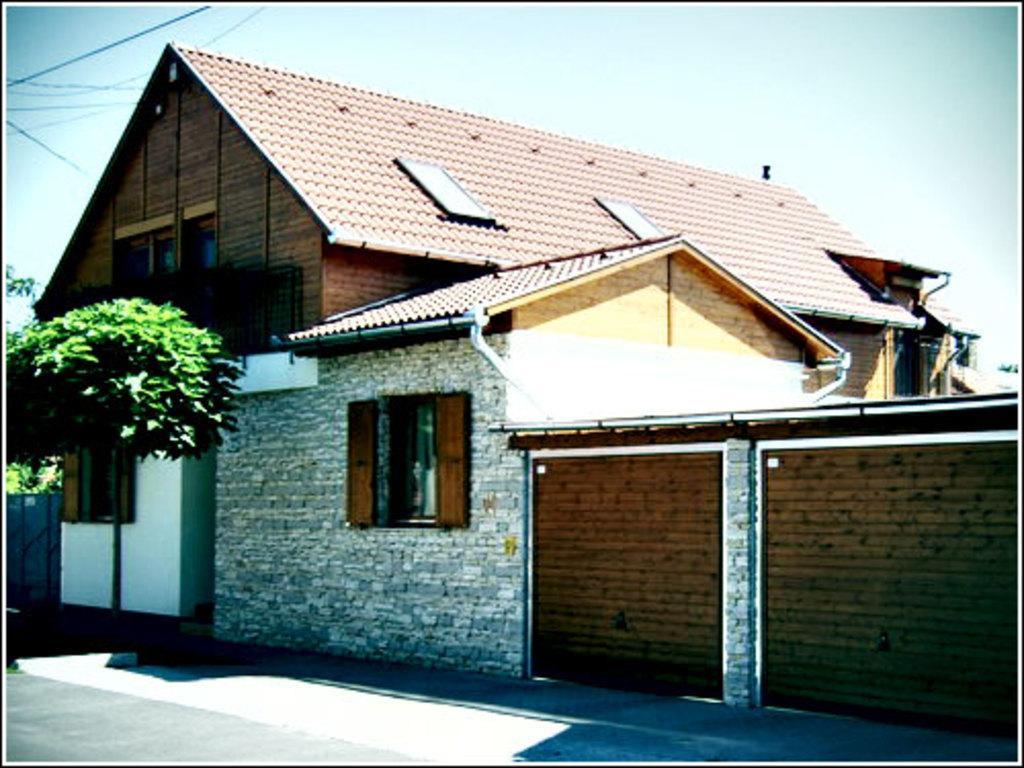Describe this image in one or two sentences. In this image we can see a house and a tree. Bottom of the image road is there. 